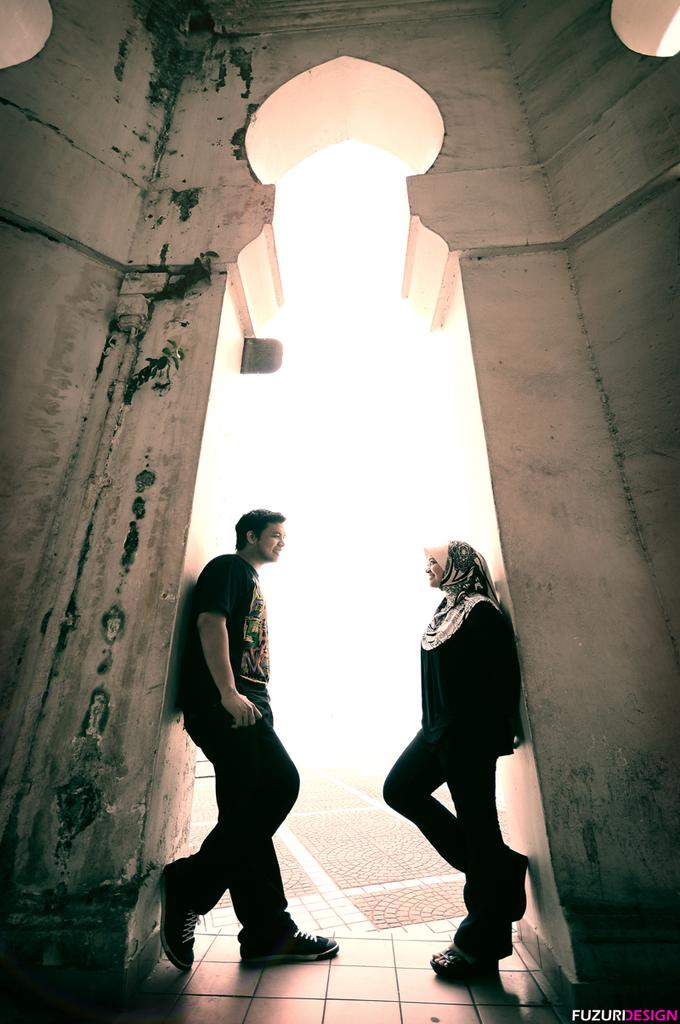Who are the people in the image? There is a man and a woman in the image. What are the man and woman doing in the image? They are standing on the floor near the walls of a building. What is the color of the background in the image? The background of the image is dark in color. What type of whistle can be heard in the image? There is no whistle present in the image, and therefore no sound can be heard. What kind of board is being used by the man and woman in the image? There is no board present in the image; the man and woman are simply standing near the walls of a building. 